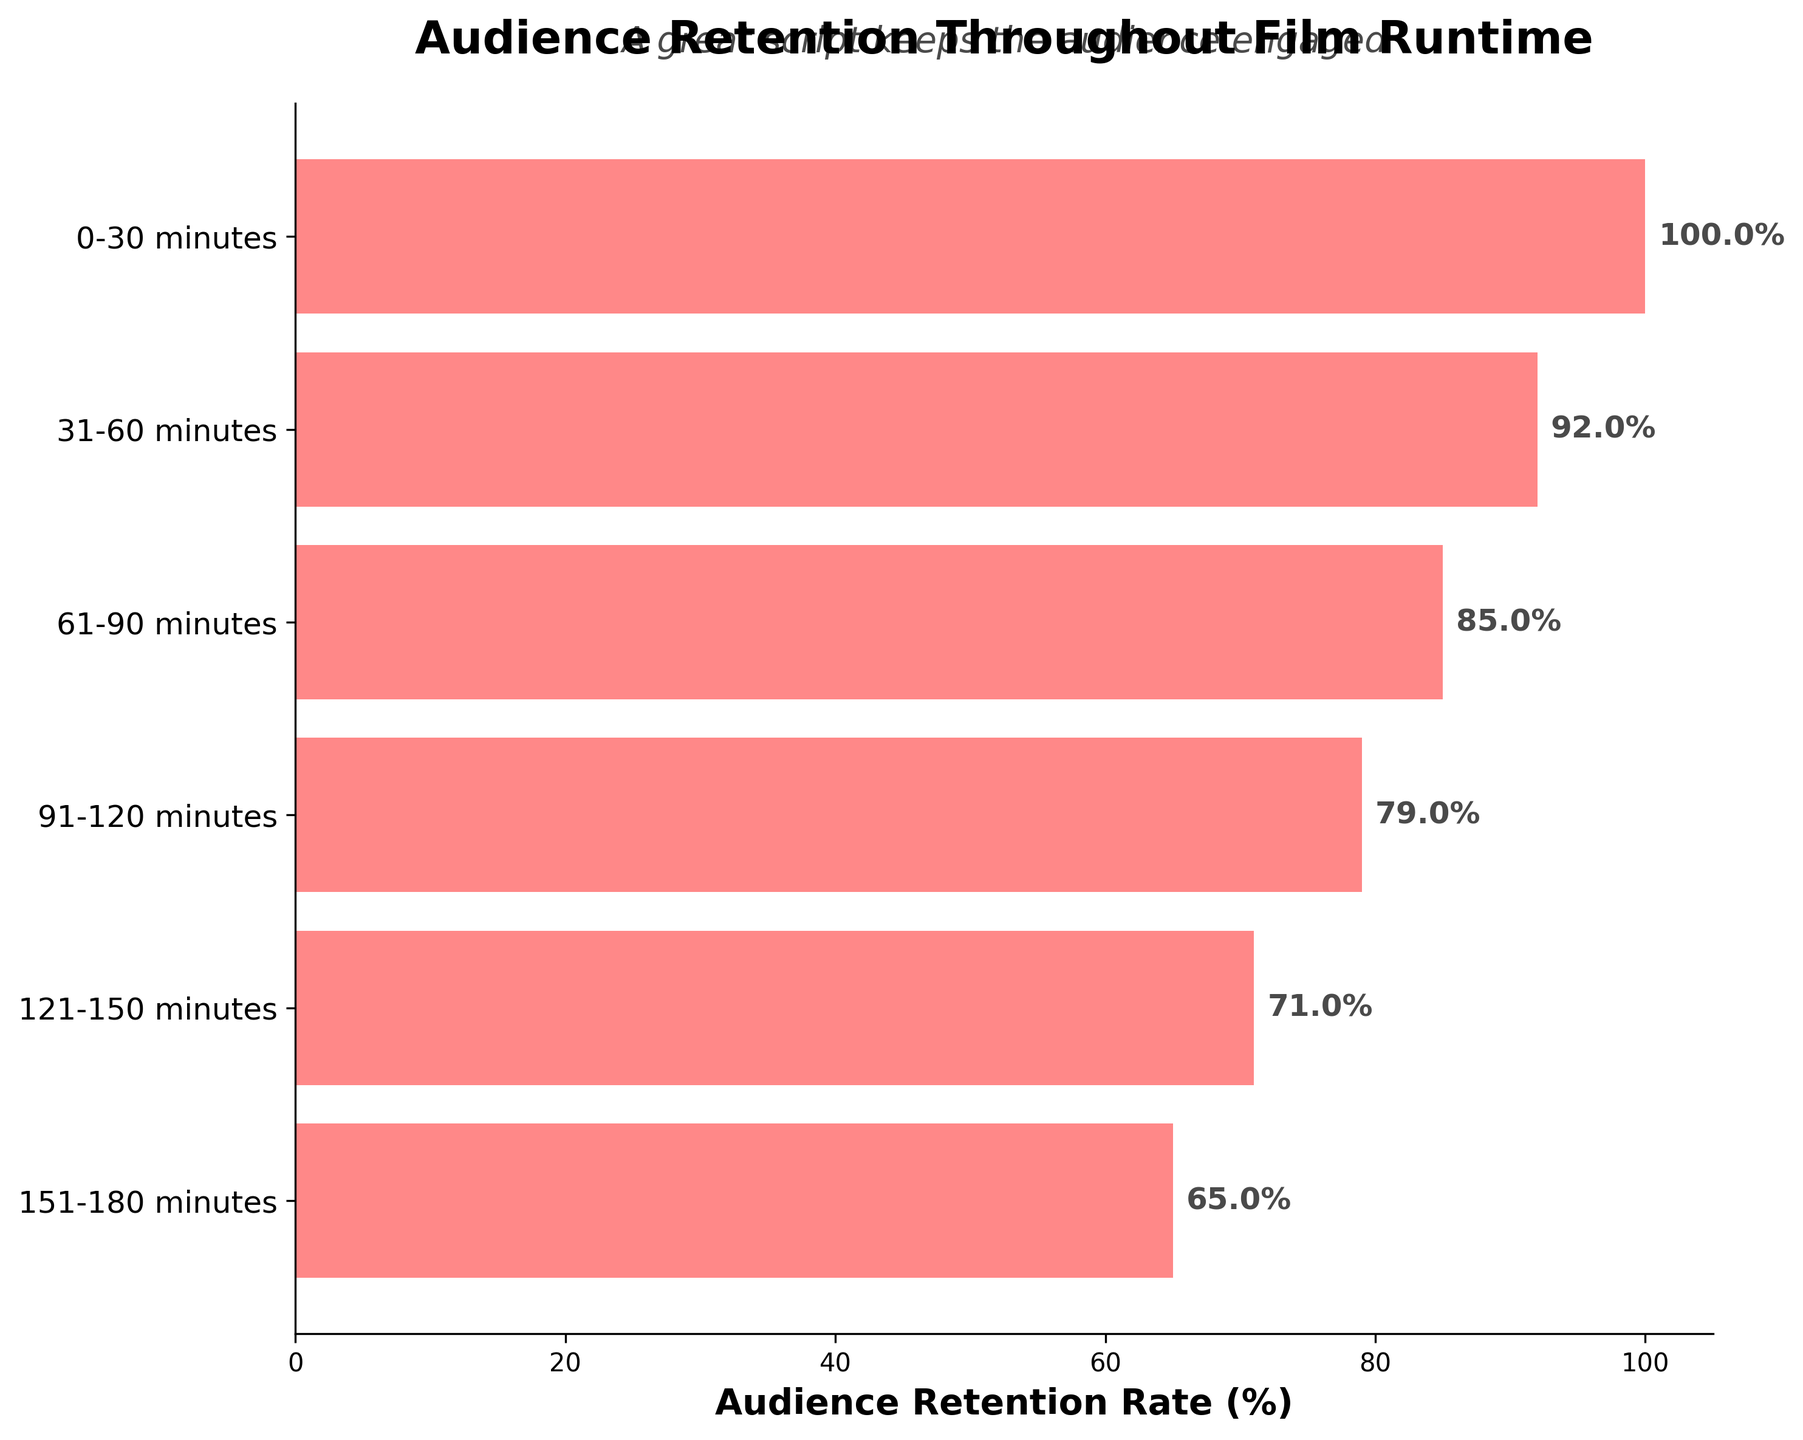What is the title of the funnel chart? The title of the funnel chart is located at the top of the figure.
Answer: Audience Retention Throughout Film Runtime What is the audience retention rate at 31-60 minutes? To find this, look at the horizontal bar corresponding to the 31-60 minute interval and read the percentage shown.
Answer: 92% How does the audience retention rate change from 0-30 minutes to 91-120 minutes? Subtract the audience retention rate at 91-120 minutes from the rate at 0-30 minutes. 100% - 79% = 21%.
Answer: It decreases by 21% Which interval has the lowest audience retention rate? The lowest audience retention rate corresponds to the shortest bar on the chart.
Answer: 151-180 minutes What is the average audience retention rate across all intervals? Add all the retention rates and divide by the number of intervals. (100 + 92 + 85 + 79 + 71 + 65) / 6 = 82%.
Answer: 82% How much does the audience retention rate drop from 61-90 minutes to 151-180 minutes? Subtract the audience retention rate at 151-180 minutes from the rate at 61-90 minutes. 85% - 65% = 20%.
Answer: It drops by 20% By how many percentage points is the retention rate higher in the 31-60 minute interval than in the 121-150 minute interval? Subtract the audience retention rate at 121-150 minutes from the rate at 31-60 minutes. 92% - 71% = 21%.
Answer: 21 percentage points Which intervals saw more than a 10% drop in audience retention compared to the previous interval? Compare each interval's retention rate to the previous one to identify drops greater than 10%. The relevant drops are from 0-30 to 31-60 (8%), 61-90 to 91-120 (6%), and 121-150 to 151-180 (6%). Therefore, there are none.
Answer: None If retaining a 75% audience is considered a success, which intervals fail to meet this criterion? Identify intervals where the retention rate is below 75%. 121-150 minutes (71%) and 151-180 minutes (65%) fall below the 75% threshold.
Answer: 121-150 minutes, 151-180 minutes What is the total decrease in audience retention rate from the beginning of the film to the end? Subtract the audience retention rate at 151-180 minutes from the rate at 0-30 minutes. 100% - 65% = 35%.
Answer: 35% 